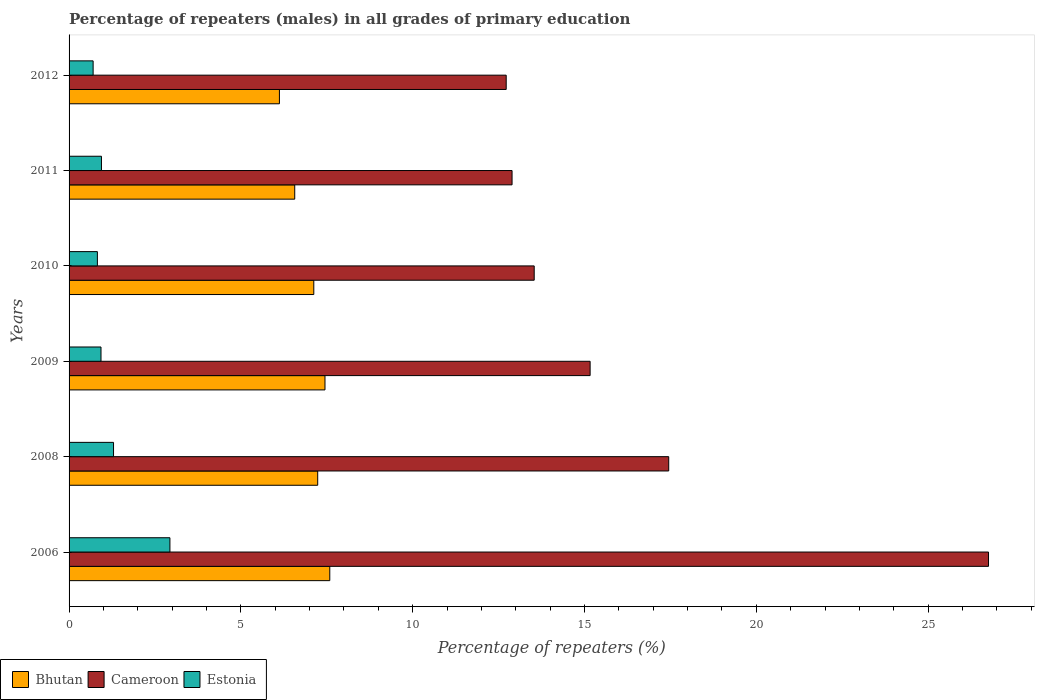How many different coloured bars are there?
Your response must be concise. 3. Are the number of bars per tick equal to the number of legend labels?
Give a very brief answer. Yes. What is the label of the 6th group of bars from the top?
Make the answer very short. 2006. In how many cases, is the number of bars for a given year not equal to the number of legend labels?
Your response must be concise. 0. What is the percentage of repeaters (males) in Bhutan in 2008?
Provide a succinct answer. 7.24. Across all years, what is the maximum percentage of repeaters (males) in Cameroon?
Provide a short and direct response. 26.76. Across all years, what is the minimum percentage of repeaters (males) in Cameroon?
Your answer should be compact. 12.72. In which year was the percentage of repeaters (males) in Estonia maximum?
Your answer should be compact. 2006. In which year was the percentage of repeaters (males) in Cameroon minimum?
Give a very brief answer. 2012. What is the total percentage of repeaters (males) in Bhutan in the graph?
Your answer should be very brief. 42.08. What is the difference between the percentage of repeaters (males) in Cameroon in 2011 and that in 2012?
Offer a terse response. 0.17. What is the difference between the percentage of repeaters (males) in Estonia in 2010 and the percentage of repeaters (males) in Cameroon in 2009?
Your answer should be very brief. -14.34. What is the average percentage of repeaters (males) in Bhutan per year?
Keep it short and to the point. 7.01. In the year 2012, what is the difference between the percentage of repeaters (males) in Bhutan and percentage of repeaters (males) in Estonia?
Your answer should be very brief. 5.42. In how many years, is the percentage of repeaters (males) in Bhutan greater than 25 %?
Make the answer very short. 0. What is the ratio of the percentage of repeaters (males) in Cameroon in 2006 to that in 2010?
Your response must be concise. 1.98. Is the percentage of repeaters (males) in Cameroon in 2006 less than that in 2010?
Provide a succinct answer. No. Is the difference between the percentage of repeaters (males) in Bhutan in 2008 and 2011 greater than the difference between the percentage of repeaters (males) in Estonia in 2008 and 2011?
Ensure brevity in your answer.  Yes. What is the difference between the highest and the second highest percentage of repeaters (males) in Cameroon?
Offer a terse response. 9.31. What is the difference between the highest and the lowest percentage of repeaters (males) in Estonia?
Your answer should be very brief. 2.23. In how many years, is the percentage of repeaters (males) in Cameroon greater than the average percentage of repeaters (males) in Cameroon taken over all years?
Give a very brief answer. 2. Is the sum of the percentage of repeaters (males) in Estonia in 2009 and 2011 greater than the maximum percentage of repeaters (males) in Cameroon across all years?
Your answer should be compact. No. What does the 1st bar from the top in 2012 represents?
Provide a short and direct response. Estonia. What does the 2nd bar from the bottom in 2010 represents?
Your response must be concise. Cameroon. Is it the case that in every year, the sum of the percentage of repeaters (males) in Estonia and percentage of repeaters (males) in Bhutan is greater than the percentage of repeaters (males) in Cameroon?
Offer a very short reply. No. Are all the bars in the graph horizontal?
Ensure brevity in your answer.  Yes. How many years are there in the graph?
Your answer should be compact. 6. What is the difference between two consecutive major ticks on the X-axis?
Make the answer very short. 5. How are the legend labels stacked?
Offer a terse response. Horizontal. What is the title of the graph?
Your answer should be compact. Percentage of repeaters (males) in all grades of primary education. Does "Thailand" appear as one of the legend labels in the graph?
Your response must be concise. No. What is the label or title of the X-axis?
Offer a terse response. Percentage of repeaters (%). What is the Percentage of repeaters (%) of Bhutan in 2006?
Make the answer very short. 7.59. What is the Percentage of repeaters (%) in Cameroon in 2006?
Offer a very short reply. 26.76. What is the Percentage of repeaters (%) of Estonia in 2006?
Your response must be concise. 2.93. What is the Percentage of repeaters (%) in Bhutan in 2008?
Provide a succinct answer. 7.24. What is the Percentage of repeaters (%) in Cameroon in 2008?
Provide a succinct answer. 17.45. What is the Percentage of repeaters (%) of Estonia in 2008?
Keep it short and to the point. 1.29. What is the Percentage of repeaters (%) in Bhutan in 2009?
Provide a succinct answer. 7.45. What is the Percentage of repeaters (%) in Cameroon in 2009?
Ensure brevity in your answer.  15.16. What is the Percentage of repeaters (%) in Estonia in 2009?
Make the answer very short. 0.93. What is the Percentage of repeaters (%) in Bhutan in 2010?
Keep it short and to the point. 7.12. What is the Percentage of repeaters (%) of Cameroon in 2010?
Offer a terse response. 13.54. What is the Percentage of repeaters (%) of Estonia in 2010?
Your response must be concise. 0.82. What is the Percentage of repeaters (%) of Bhutan in 2011?
Offer a very short reply. 6.57. What is the Percentage of repeaters (%) in Cameroon in 2011?
Your answer should be compact. 12.89. What is the Percentage of repeaters (%) in Estonia in 2011?
Make the answer very short. 0.94. What is the Percentage of repeaters (%) in Bhutan in 2012?
Offer a very short reply. 6.12. What is the Percentage of repeaters (%) in Cameroon in 2012?
Offer a terse response. 12.72. What is the Percentage of repeaters (%) of Estonia in 2012?
Provide a short and direct response. 0.7. Across all years, what is the maximum Percentage of repeaters (%) of Bhutan?
Your response must be concise. 7.59. Across all years, what is the maximum Percentage of repeaters (%) in Cameroon?
Ensure brevity in your answer.  26.76. Across all years, what is the maximum Percentage of repeaters (%) of Estonia?
Provide a short and direct response. 2.93. Across all years, what is the minimum Percentage of repeaters (%) in Bhutan?
Your response must be concise. 6.12. Across all years, what is the minimum Percentage of repeaters (%) of Cameroon?
Your answer should be very brief. 12.72. Across all years, what is the minimum Percentage of repeaters (%) of Estonia?
Provide a short and direct response. 0.7. What is the total Percentage of repeaters (%) in Bhutan in the graph?
Ensure brevity in your answer.  42.08. What is the total Percentage of repeaters (%) of Cameroon in the graph?
Ensure brevity in your answer.  98.52. What is the total Percentage of repeaters (%) in Estonia in the graph?
Keep it short and to the point. 7.62. What is the difference between the Percentage of repeaters (%) in Bhutan in 2006 and that in 2008?
Keep it short and to the point. 0.35. What is the difference between the Percentage of repeaters (%) in Cameroon in 2006 and that in 2008?
Ensure brevity in your answer.  9.31. What is the difference between the Percentage of repeaters (%) of Estonia in 2006 and that in 2008?
Your response must be concise. 1.64. What is the difference between the Percentage of repeaters (%) in Bhutan in 2006 and that in 2009?
Give a very brief answer. 0.14. What is the difference between the Percentage of repeaters (%) in Cameroon in 2006 and that in 2009?
Your answer should be compact. 11.59. What is the difference between the Percentage of repeaters (%) of Estonia in 2006 and that in 2009?
Give a very brief answer. 2.01. What is the difference between the Percentage of repeaters (%) in Bhutan in 2006 and that in 2010?
Keep it short and to the point. 0.47. What is the difference between the Percentage of repeaters (%) in Cameroon in 2006 and that in 2010?
Provide a short and direct response. 13.22. What is the difference between the Percentage of repeaters (%) of Estonia in 2006 and that in 2010?
Give a very brief answer. 2.11. What is the difference between the Percentage of repeaters (%) in Cameroon in 2006 and that in 2011?
Offer a terse response. 13.87. What is the difference between the Percentage of repeaters (%) in Estonia in 2006 and that in 2011?
Make the answer very short. 1.99. What is the difference between the Percentage of repeaters (%) of Bhutan in 2006 and that in 2012?
Provide a short and direct response. 1.47. What is the difference between the Percentage of repeaters (%) in Cameroon in 2006 and that in 2012?
Ensure brevity in your answer.  14.04. What is the difference between the Percentage of repeaters (%) in Estonia in 2006 and that in 2012?
Make the answer very short. 2.23. What is the difference between the Percentage of repeaters (%) of Bhutan in 2008 and that in 2009?
Offer a very short reply. -0.21. What is the difference between the Percentage of repeaters (%) of Cameroon in 2008 and that in 2009?
Offer a very short reply. 2.29. What is the difference between the Percentage of repeaters (%) of Estonia in 2008 and that in 2009?
Your response must be concise. 0.36. What is the difference between the Percentage of repeaters (%) of Bhutan in 2008 and that in 2010?
Ensure brevity in your answer.  0.11. What is the difference between the Percentage of repeaters (%) of Cameroon in 2008 and that in 2010?
Your answer should be very brief. 3.91. What is the difference between the Percentage of repeaters (%) of Estonia in 2008 and that in 2010?
Make the answer very short. 0.47. What is the difference between the Percentage of repeaters (%) in Bhutan in 2008 and that in 2011?
Keep it short and to the point. 0.67. What is the difference between the Percentage of repeaters (%) of Cameroon in 2008 and that in 2011?
Make the answer very short. 4.56. What is the difference between the Percentage of repeaters (%) in Estonia in 2008 and that in 2011?
Your answer should be compact. 0.35. What is the difference between the Percentage of repeaters (%) of Bhutan in 2008 and that in 2012?
Ensure brevity in your answer.  1.11. What is the difference between the Percentage of repeaters (%) of Cameroon in 2008 and that in 2012?
Ensure brevity in your answer.  4.73. What is the difference between the Percentage of repeaters (%) in Estonia in 2008 and that in 2012?
Your answer should be very brief. 0.59. What is the difference between the Percentage of repeaters (%) of Bhutan in 2009 and that in 2010?
Offer a terse response. 0.33. What is the difference between the Percentage of repeaters (%) of Cameroon in 2009 and that in 2010?
Your response must be concise. 1.63. What is the difference between the Percentage of repeaters (%) of Estonia in 2009 and that in 2010?
Make the answer very short. 0.11. What is the difference between the Percentage of repeaters (%) in Bhutan in 2009 and that in 2011?
Offer a terse response. 0.88. What is the difference between the Percentage of repeaters (%) of Cameroon in 2009 and that in 2011?
Keep it short and to the point. 2.27. What is the difference between the Percentage of repeaters (%) of Estonia in 2009 and that in 2011?
Offer a very short reply. -0.01. What is the difference between the Percentage of repeaters (%) in Bhutan in 2009 and that in 2012?
Provide a short and direct response. 1.33. What is the difference between the Percentage of repeaters (%) of Cameroon in 2009 and that in 2012?
Offer a terse response. 2.44. What is the difference between the Percentage of repeaters (%) of Estonia in 2009 and that in 2012?
Your response must be concise. 0.23. What is the difference between the Percentage of repeaters (%) of Bhutan in 2010 and that in 2011?
Provide a short and direct response. 0.55. What is the difference between the Percentage of repeaters (%) of Cameroon in 2010 and that in 2011?
Keep it short and to the point. 0.64. What is the difference between the Percentage of repeaters (%) in Estonia in 2010 and that in 2011?
Ensure brevity in your answer.  -0.12. What is the difference between the Percentage of repeaters (%) in Cameroon in 2010 and that in 2012?
Provide a succinct answer. 0.81. What is the difference between the Percentage of repeaters (%) in Estonia in 2010 and that in 2012?
Ensure brevity in your answer.  0.12. What is the difference between the Percentage of repeaters (%) of Bhutan in 2011 and that in 2012?
Make the answer very short. 0.45. What is the difference between the Percentage of repeaters (%) in Cameroon in 2011 and that in 2012?
Offer a very short reply. 0.17. What is the difference between the Percentage of repeaters (%) in Estonia in 2011 and that in 2012?
Offer a terse response. 0.24. What is the difference between the Percentage of repeaters (%) in Bhutan in 2006 and the Percentage of repeaters (%) in Cameroon in 2008?
Your answer should be compact. -9.86. What is the difference between the Percentage of repeaters (%) in Bhutan in 2006 and the Percentage of repeaters (%) in Estonia in 2008?
Make the answer very short. 6.29. What is the difference between the Percentage of repeaters (%) in Cameroon in 2006 and the Percentage of repeaters (%) in Estonia in 2008?
Give a very brief answer. 25.46. What is the difference between the Percentage of repeaters (%) in Bhutan in 2006 and the Percentage of repeaters (%) in Cameroon in 2009?
Your answer should be very brief. -7.58. What is the difference between the Percentage of repeaters (%) of Bhutan in 2006 and the Percentage of repeaters (%) of Estonia in 2009?
Your answer should be compact. 6.66. What is the difference between the Percentage of repeaters (%) in Cameroon in 2006 and the Percentage of repeaters (%) in Estonia in 2009?
Offer a very short reply. 25.83. What is the difference between the Percentage of repeaters (%) in Bhutan in 2006 and the Percentage of repeaters (%) in Cameroon in 2010?
Make the answer very short. -5.95. What is the difference between the Percentage of repeaters (%) in Bhutan in 2006 and the Percentage of repeaters (%) in Estonia in 2010?
Keep it short and to the point. 6.76. What is the difference between the Percentage of repeaters (%) of Cameroon in 2006 and the Percentage of repeaters (%) of Estonia in 2010?
Provide a short and direct response. 25.93. What is the difference between the Percentage of repeaters (%) of Bhutan in 2006 and the Percentage of repeaters (%) of Cameroon in 2011?
Provide a short and direct response. -5.3. What is the difference between the Percentage of repeaters (%) in Bhutan in 2006 and the Percentage of repeaters (%) in Estonia in 2011?
Offer a terse response. 6.64. What is the difference between the Percentage of repeaters (%) of Cameroon in 2006 and the Percentage of repeaters (%) of Estonia in 2011?
Your answer should be compact. 25.81. What is the difference between the Percentage of repeaters (%) of Bhutan in 2006 and the Percentage of repeaters (%) of Cameroon in 2012?
Your answer should be compact. -5.13. What is the difference between the Percentage of repeaters (%) of Bhutan in 2006 and the Percentage of repeaters (%) of Estonia in 2012?
Make the answer very short. 6.89. What is the difference between the Percentage of repeaters (%) of Cameroon in 2006 and the Percentage of repeaters (%) of Estonia in 2012?
Provide a short and direct response. 26.06. What is the difference between the Percentage of repeaters (%) of Bhutan in 2008 and the Percentage of repeaters (%) of Cameroon in 2009?
Keep it short and to the point. -7.93. What is the difference between the Percentage of repeaters (%) of Bhutan in 2008 and the Percentage of repeaters (%) of Estonia in 2009?
Your answer should be compact. 6.31. What is the difference between the Percentage of repeaters (%) of Cameroon in 2008 and the Percentage of repeaters (%) of Estonia in 2009?
Provide a succinct answer. 16.52. What is the difference between the Percentage of repeaters (%) in Bhutan in 2008 and the Percentage of repeaters (%) in Cameroon in 2010?
Provide a short and direct response. -6.3. What is the difference between the Percentage of repeaters (%) in Bhutan in 2008 and the Percentage of repeaters (%) in Estonia in 2010?
Your answer should be very brief. 6.41. What is the difference between the Percentage of repeaters (%) of Cameroon in 2008 and the Percentage of repeaters (%) of Estonia in 2010?
Offer a terse response. 16.63. What is the difference between the Percentage of repeaters (%) in Bhutan in 2008 and the Percentage of repeaters (%) in Cameroon in 2011?
Your answer should be very brief. -5.66. What is the difference between the Percentage of repeaters (%) of Bhutan in 2008 and the Percentage of repeaters (%) of Estonia in 2011?
Offer a very short reply. 6.29. What is the difference between the Percentage of repeaters (%) of Cameroon in 2008 and the Percentage of repeaters (%) of Estonia in 2011?
Give a very brief answer. 16.51. What is the difference between the Percentage of repeaters (%) of Bhutan in 2008 and the Percentage of repeaters (%) of Cameroon in 2012?
Make the answer very short. -5.49. What is the difference between the Percentage of repeaters (%) in Bhutan in 2008 and the Percentage of repeaters (%) in Estonia in 2012?
Offer a very short reply. 6.54. What is the difference between the Percentage of repeaters (%) of Cameroon in 2008 and the Percentage of repeaters (%) of Estonia in 2012?
Provide a succinct answer. 16.75. What is the difference between the Percentage of repeaters (%) of Bhutan in 2009 and the Percentage of repeaters (%) of Cameroon in 2010?
Your response must be concise. -6.09. What is the difference between the Percentage of repeaters (%) of Bhutan in 2009 and the Percentage of repeaters (%) of Estonia in 2010?
Keep it short and to the point. 6.62. What is the difference between the Percentage of repeaters (%) in Cameroon in 2009 and the Percentage of repeaters (%) in Estonia in 2010?
Offer a very short reply. 14.34. What is the difference between the Percentage of repeaters (%) of Bhutan in 2009 and the Percentage of repeaters (%) of Cameroon in 2011?
Offer a very short reply. -5.44. What is the difference between the Percentage of repeaters (%) in Bhutan in 2009 and the Percentage of repeaters (%) in Estonia in 2011?
Offer a very short reply. 6.51. What is the difference between the Percentage of repeaters (%) of Cameroon in 2009 and the Percentage of repeaters (%) of Estonia in 2011?
Provide a short and direct response. 14.22. What is the difference between the Percentage of repeaters (%) in Bhutan in 2009 and the Percentage of repeaters (%) in Cameroon in 2012?
Provide a succinct answer. -5.27. What is the difference between the Percentage of repeaters (%) of Bhutan in 2009 and the Percentage of repeaters (%) of Estonia in 2012?
Your answer should be compact. 6.75. What is the difference between the Percentage of repeaters (%) of Cameroon in 2009 and the Percentage of repeaters (%) of Estonia in 2012?
Your answer should be very brief. 14.46. What is the difference between the Percentage of repeaters (%) of Bhutan in 2010 and the Percentage of repeaters (%) of Cameroon in 2011?
Offer a very short reply. -5.77. What is the difference between the Percentage of repeaters (%) in Bhutan in 2010 and the Percentage of repeaters (%) in Estonia in 2011?
Make the answer very short. 6.18. What is the difference between the Percentage of repeaters (%) of Cameroon in 2010 and the Percentage of repeaters (%) of Estonia in 2011?
Offer a very short reply. 12.59. What is the difference between the Percentage of repeaters (%) in Bhutan in 2010 and the Percentage of repeaters (%) in Cameroon in 2012?
Offer a very short reply. -5.6. What is the difference between the Percentage of repeaters (%) of Bhutan in 2010 and the Percentage of repeaters (%) of Estonia in 2012?
Ensure brevity in your answer.  6.42. What is the difference between the Percentage of repeaters (%) in Cameroon in 2010 and the Percentage of repeaters (%) in Estonia in 2012?
Ensure brevity in your answer.  12.84. What is the difference between the Percentage of repeaters (%) in Bhutan in 2011 and the Percentage of repeaters (%) in Cameroon in 2012?
Offer a terse response. -6.15. What is the difference between the Percentage of repeaters (%) of Bhutan in 2011 and the Percentage of repeaters (%) of Estonia in 2012?
Your answer should be compact. 5.87. What is the difference between the Percentage of repeaters (%) in Cameroon in 2011 and the Percentage of repeaters (%) in Estonia in 2012?
Provide a succinct answer. 12.19. What is the average Percentage of repeaters (%) in Bhutan per year?
Keep it short and to the point. 7.01. What is the average Percentage of repeaters (%) in Cameroon per year?
Provide a succinct answer. 16.42. What is the average Percentage of repeaters (%) of Estonia per year?
Provide a succinct answer. 1.27. In the year 2006, what is the difference between the Percentage of repeaters (%) of Bhutan and Percentage of repeaters (%) of Cameroon?
Ensure brevity in your answer.  -19.17. In the year 2006, what is the difference between the Percentage of repeaters (%) in Bhutan and Percentage of repeaters (%) in Estonia?
Your answer should be very brief. 4.65. In the year 2006, what is the difference between the Percentage of repeaters (%) of Cameroon and Percentage of repeaters (%) of Estonia?
Offer a terse response. 23.82. In the year 2008, what is the difference between the Percentage of repeaters (%) in Bhutan and Percentage of repeaters (%) in Cameroon?
Your answer should be compact. -10.21. In the year 2008, what is the difference between the Percentage of repeaters (%) in Bhutan and Percentage of repeaters (%) in Estonia?
Your answer should be very brief. 5.94. In the year 2008, what is the difference between the Percentage of repeaters (%) in Cameroon and Percentage of repeaters (%) in Estonia?
Your answer should be compact. 16.16. In the year 2009, what is the difference between the Percentage of repeaters (%) of Bhutan and Percentage of repeaters (%) of Cameroon?
Provide a short and direct response. -7.72. In the year 2009, what is the difference between the Percentage of repeaters (%) of Bhutan and Percentage of repeaters (%) of Estonia?
Your answer should be compact. 6.52. In the year 2009, what is the difference between the Percentage of repeaters (%) in Cameroon and Percentage of repeaters (%) in Estonia?
Keep it short and to the point. 14.23. In the year 2010, what is the difference between the Percentage of repeaters (%) of Bhutan and Percentage of repeaters (%) of Cameroon?
Offer a terse response. -6.41. In the year 2010, what is the difference between the Percentage of repeaters (%) of Bhutan and Percentage of repeaters (%) of Estonia?
Your answer should be very brief. 6.3. In the year 2010, what is the difference between the Percentage of repeaters (%) of Cameroon and Percentage of repeaters (%) of Estonia?
Your answer should be compact. 12.71. In the year 2011, what is the difference between the Percentage of repeaters (%) in Bhutan and Percentage of repeaters (%) in Cameroon?
Your answer should be very brief. -6.32. In the year 2011, what is the difference between the Percentage of repeaters (%) of Bhutan and Percentage of repeaters (%) of Estonia?
Make the answer very short. 5.62. In the year 2011, what is the difference between the Percentage of repeaters (%) of Cameroon and Percentage of repeaters (%) of Estonia?
Offer a terse response. 11.95. In the year 2012, what is the difference between the Percentage of repeaters (%) of Bhutan and Percentage of repeaters (%) of Cameroon?
Make the answer very short. -6.6. In the year 2012, what is the difference between the Percentage of repeaters (%) of Bhutan and Percentage of repeaters (%) of Estonia?
Offer a terse response. 5.42. In the year 2012, what is the difference between the Percentage of repeaters (%) of Cameroon and Percentage of repeaters (%) of Estonia?
Keep it short and to the point. 12.02. What is the ratio of the Percentage of repeaters (%) of Bhutan in 2006 to that in 2008?
Give a very brief answer. 1.05. What is the ratio of the Percentage of repeaters (%) in Cameroon in 2006 to that in 2008?
Your answer should be very brief. 1.53. What is the ratio of the Percentage of repeaters (%) in Estonia in 2006 to that in 2008?
Keep it short and to the point. 2.27. What is the ratio of the Percentage of repeaters (%) of Bhutan in 2006 to that in 2009?
Provide a succinct answer. 1.02. What is the ratio of the Percentage of repeaters (%) of Cameroon in 2006 to that in 2009?
Provide a short and direct response. 1.76. What is the ratio of the Percentage of repeaters (%) of Estonia in 2006 to that in 2009?
Ensure brevity in your answer.  3.16. What is the ratio of the Percentage of repeaters (%) in Bhutan in 2006 to that in 2010?
Give a very brief answer. 1.07. What is the ratio of the Percentage of repeaters (%) in Cameroon in 2006 to that in 2010?
Provide a short and direct response. 1.98. What is the ratio of the Percentage of repeaters (%) in Estonia in 2006 to that in 2010?
Your response must be concise. 3.56. What is the ratio of the Percentage of repeaters (%) in Bhutan in 2006 to that in 2011?
Provide a succinct answer. 1.16. What is the ratio of the Percentage of repeaters (%) of Cameroon in 2006 to that in 2011?
Your answer should be very brief. 2.08. What is the ratio of the Percentage of repeaters (%) of Estonia in 2006 to that in 2011?
Ensure brevity in your answer.  3.12. What is the ratio of the Percentage of repeaters (%) in Bhutan in 2006 to that in 2012?
Your answer should be compact. 1.24. What is the ratio of the Percentage of repeaters (%) in Cameroon in 2006 to that in 2012?
Provide a succinct answer. 2.1. What is the ratio of the Percentage of repeaters (%) of Estonia in 2006 to that in 2012?
Your response must be concise. 4.19. What is the ratio of the Percentage of repeaters (%) in Bhutan in 2008 to that in 2009?
Your answer should be compact. 0.97. What is the ratio of the Percentage of repeaters (%) in Cameroon in 2008 to that in 2009?
Provide a succinct answer. 1.15. What is the ratio of the Percentage of repeaters (%) of Estonia in 2008 to that in 2009?
Make the answer very short. 1.39. What is the ratio of the Percentage of repeaters (%) in Bhutan in 2008 to that in 2010?
Provide a succinct answer. 1.02. What is the ratio of the Percentage of repeaters (%) of Cameroon in 2008 to that in 2010?
Your answer should be compact. 1.29. What is the ratio of the Percentage of repeaters (%) of Estonia in 2008 to that in 2010?
Provide a short and direct response. 1.57. What is the ratio of the Percentage of repeaters (%) in Bhutan in 2008 to that in 2011?
Your answer should be compact. 1.1. What is the ratio of the Percentage of repeaters (%) in Cameroon in 2008 to that in 2011?
Your answer should be very brief. 1.35. What is the ratio of the Percentage of repeaters (%) of Estonia in 2008 to that in 2011?
Your answer should be compact. 1.37. What is the ratio of the Percentage of repeaters (%) in Bhutan in 2008 to that in 2012?
Your answer should be compact. 1.18. What is the ratio of the Percentage of repeaters (%) in Cameroon in 2008 to that in 2012?
Provide a short and direct response. 1.37. What is the ratio of the Percentage of repeaters (%) of Estonia in 2008 to that in 2012?
Offer a terse response. 1.85. What is the ratio of the Percentage of repeaters (%) of Bhutan in 2009 to that in 2010?
Your response must be concise. 1.05. What is the ratio of the Percentage of repeaters (%) of Cameroon in 2009 to that in 2010?
Your response must be concise. 1.12. What is the ratio of the Percentage of repeaters (%) in Estonia in 2009 to that in 2010?
Ensure brevity in your answer.  1.13. What is the ratio of the Percentage of repeaters (%) in Bhutan in 2009 to that in 2011?
Your response must be concise. 1.13. What is the ratio of the Percentage of repeaters (%) of Cameroon in 2009 to that in 2011?
Keep it short and to the point. 1.18. What is the ratio of the Percentage of repeaters (%) in Estonia in 2009 to that in 2011?
Your answer should be very brief. 0.99. What is the ratio of the Percentage of repeaters (%) of Bhutan in 2009 to that in 2012?
Give a very brief answer. 1.22. What is the ratio of the Percentage of repeaters (%) in Cameroon in 2009 to that in 2012?
Offer a very short reply. 1.19. What is the ratio of the Percentage of repeaters (%) of Estonia in 2009 to that in 2012?
Make the answer very short. 1.33. What is the ratio of the Percentage of repeaters (%) of Bhutan in 2010 to that in 2011?
Give a very brief answer. 1.08. What is the ratio of the Percentage of repeaters (%) in Estonia in 2010 to that in 2011?
Provide a succinct answer. 0.87. What is the ratio of the Percentage of repeaters (%) in Bhutan in 2010 to that in 2012?
Provide a succinct answer. 1.16. What is the ratio of the Percentage of repeaters (%) in Cameroon in 2010 to that in 2012?
Make the answer very short. 1.06. What is the ratio of the Percentage of repeaters (%) of Estonia in 2010 to that in 2012?
Provide a succinct answer. 1.18. What is the ratio of the Percentage of repeaters (%) of Bhutan in 2011 to that in 2012?
Keep it short and to the point. 1.07. What is the ratio of the Percentage of repeaters (%) in Cameroon in 2011 to that in 2012?
Your response must be concise. 1.01. What is the ratio of the Percentage of repeaters (%) in Estonia in 2011 to that in 2012?
Your answer should be compact. 1.35. What is the difference between the highest and the second highest Percentage of repeaters (%) of Bhutan?
Keep it short and to the point. 0.14. What is the difference between the highest and the second highest Percentage of repeaters (%) in Cameroon?
Provide a succinct answer. 9.31. What is the difference between the highest and the second highest Percentage of repeaters (%) of Estonia?
Your answer should be compact. 1.64. What is the difference between the highest and the lowest Percentage of repeaters (%) in Bhutan?
Make the answer very short. 1.47. What is the difference between the highest and the lowest Percentage of repeaters (%) in Cameroon?
Offer a very short reply. 14.04. What is the difference between the highest and the lowest Percentage of repeaters (%) of Estonia?
Keep it short and to the point. 2.23. 